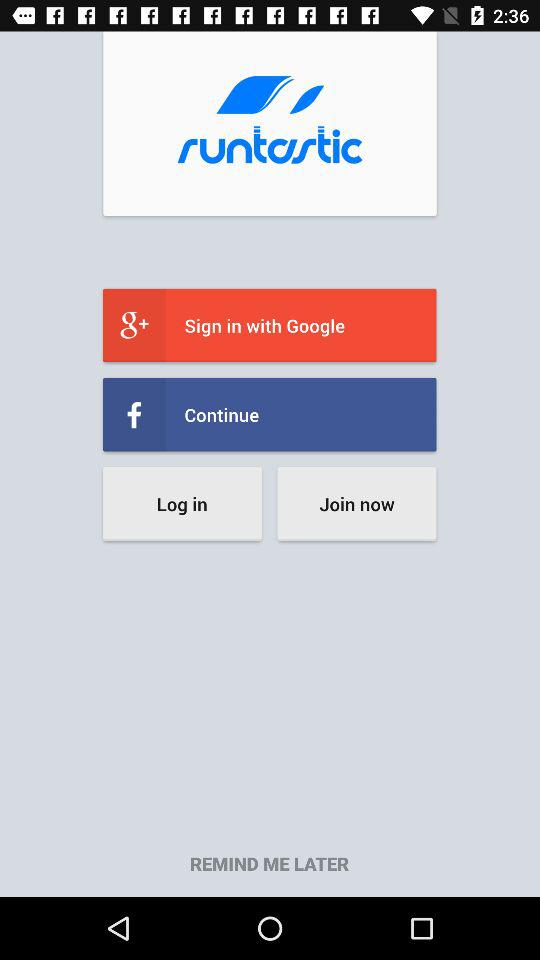Which are the different options to log in? The different options to log in are "Google+" and "Facebook". 